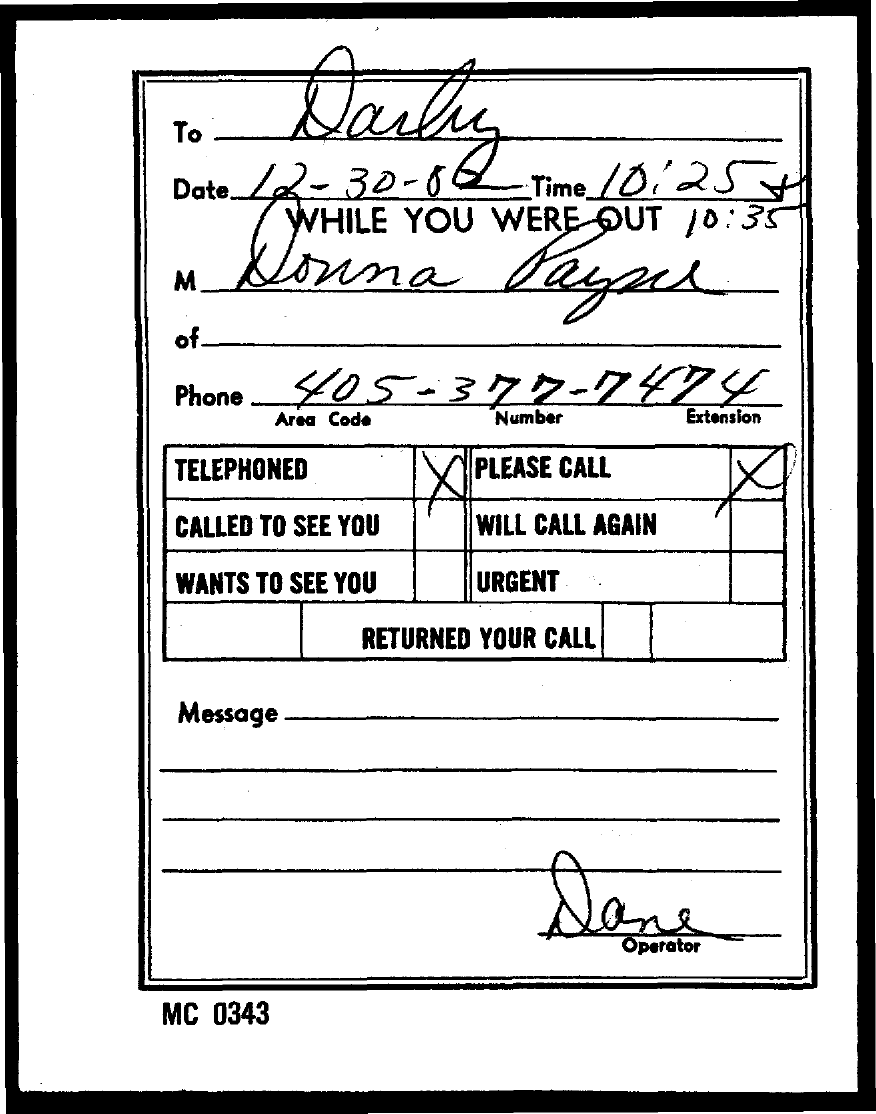What is the "Phone" number mentioned?
Ensure brevity in your answer.  405-377-7474. What is the "Area Code" ?
Your answer should be compact. 405. What is the "Number" ?
Provide a succinct answer. 377. What is the "Extension" ?
Your answer should be very brief. 7474. What is the CODE number mentioned on the left bottom of the page?
Make the answer very short. Mc 0343. 